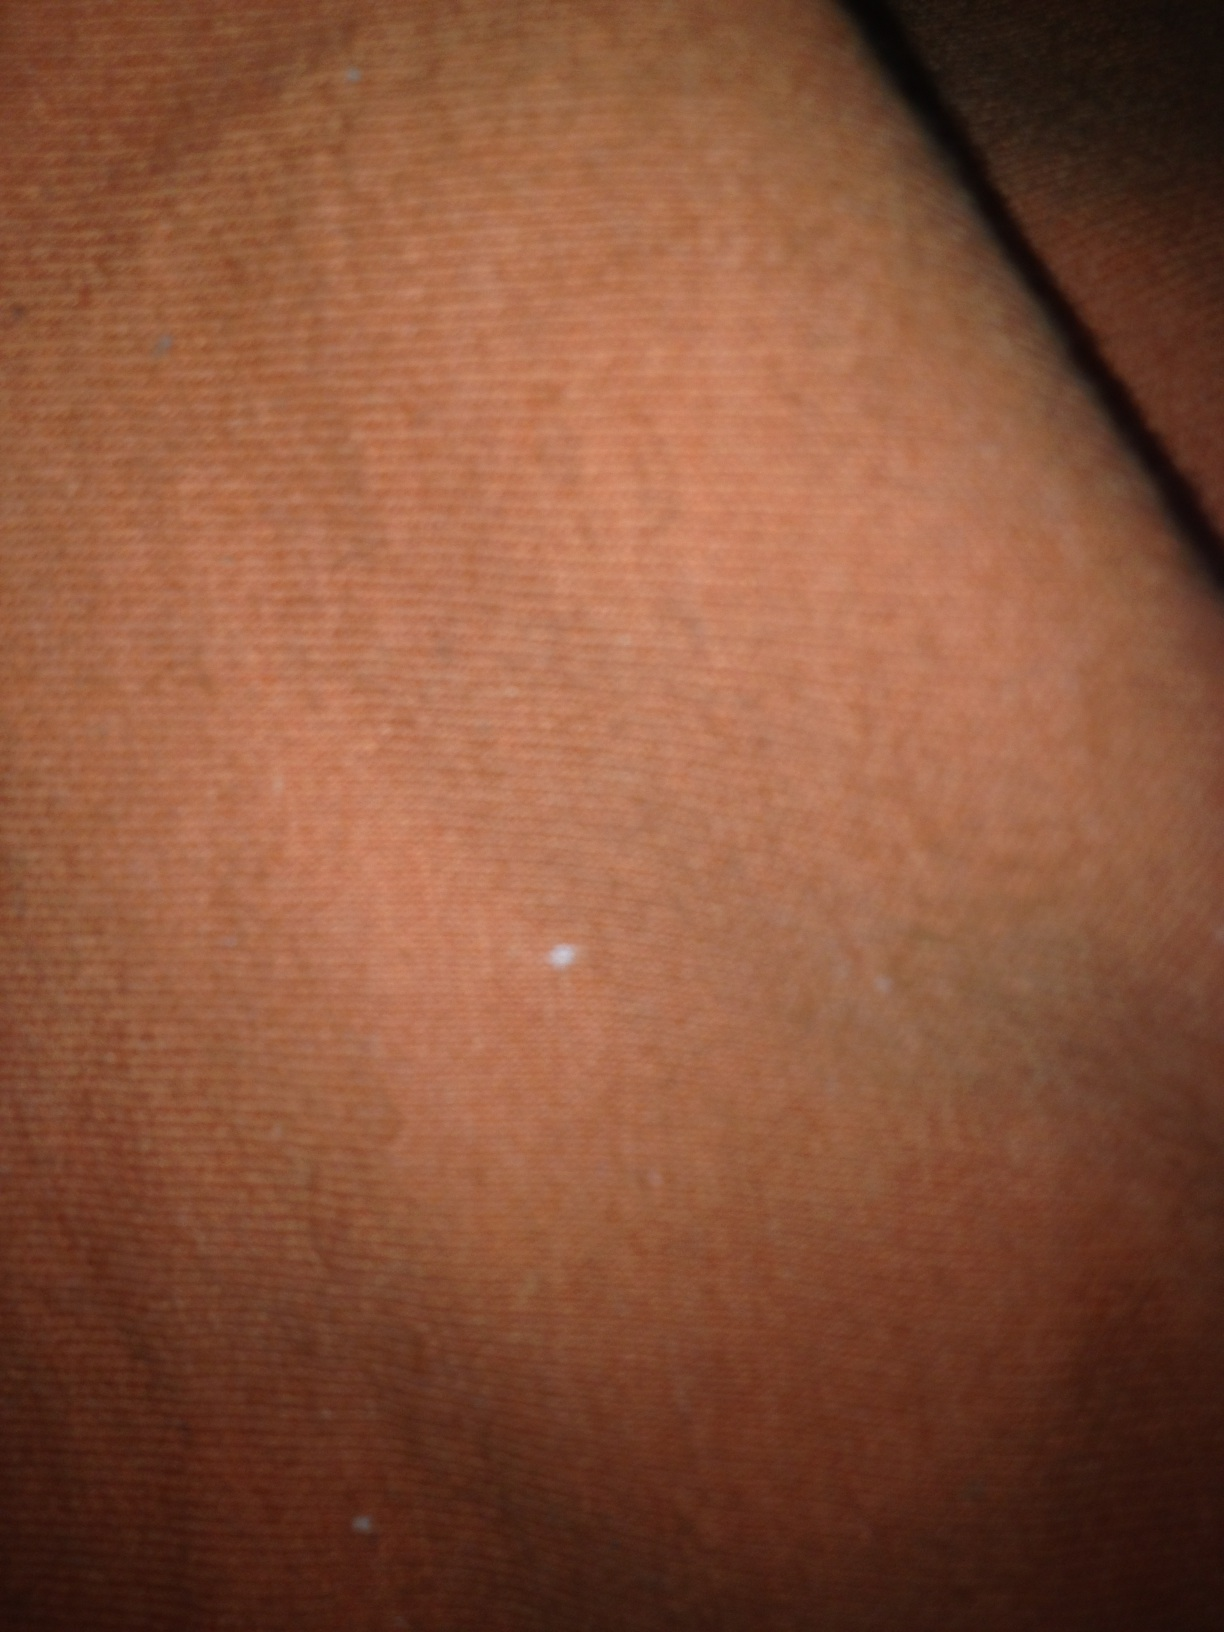What color is this? The color in this image is a shade of orange. It appears to be a warm, somewhat muted orange, possibly from a fabric or surface texture. 